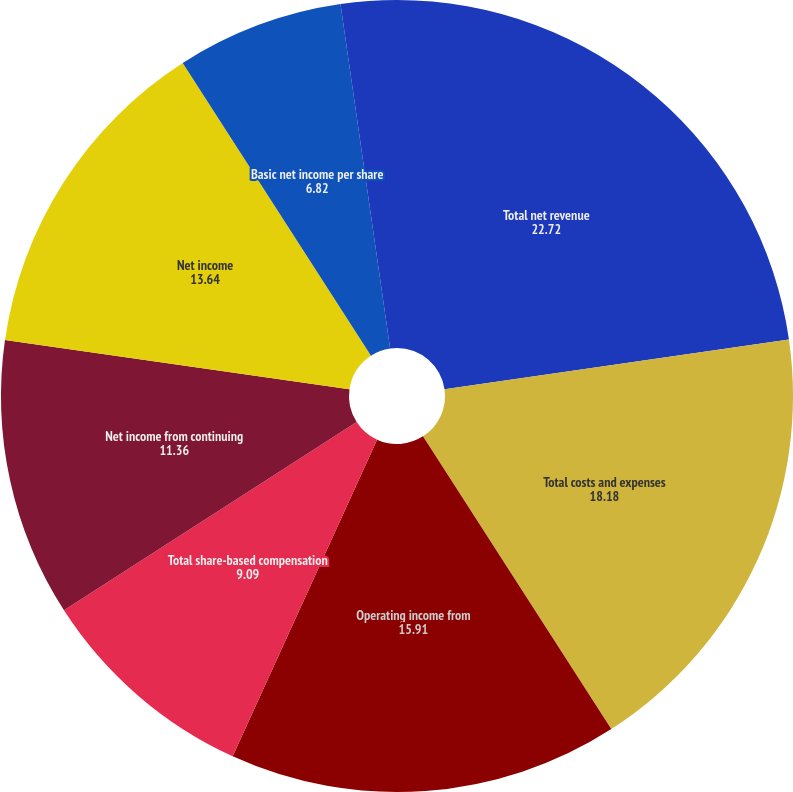Convert chart to OTSL. <chart><loc_0><loc_0><loc_500><loc_500><pie_chart><fcel>Total net revenue<fcel>Total costs and expenses<fcel>Operating income from<fcel>Total share-based compensation<fcel>Net income from continuing<fcel>Net income<fcel>Basic net income per share<fcel>Diluted net income per share<nl><fcel>22.72%<fcel>18.18%<fcel>15.91%<fcel>9.09%<fcel>11.36%<fcel>13.64%<fcel>6.82%<fcel>2.28%<nl></chart> 